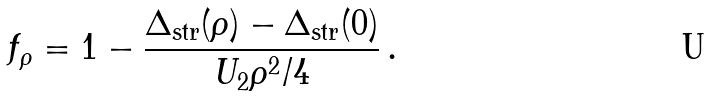Convert formula to latex. <formula><loc_0><loc_0><loc_500><loc_500>f _ { \rho } = 1 - \frac { \Delta _ { \text {str} } ( \rho ) - \Delta _ { \text {str} } ( 0 ) } { U _ { 2 } \rho ^ { 2 } / 4 } \, .</formula> 